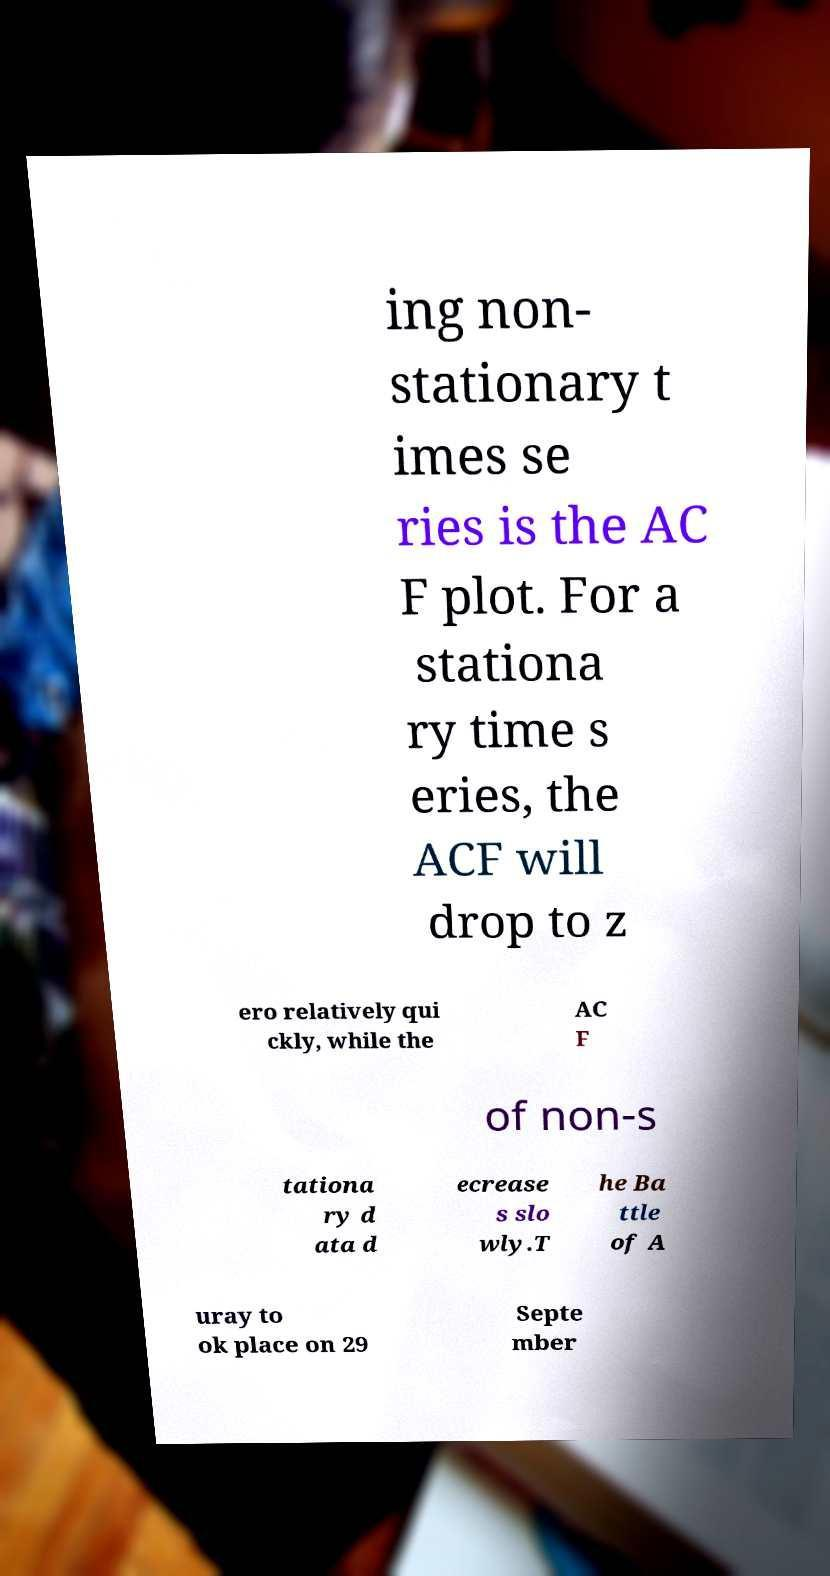What messages or text are displayed in this image? I need them in a readable, typed format. ing non- stationary t imes se ries is the AC F plot. For a stationa ry time s eries, the ACF will drop to z ero relatively qui ckly, while the AC F of non-s tationa ry d ata d ecrease s slo wly.T he Ba ttle of A uray to ok place on 29 Septe mber 